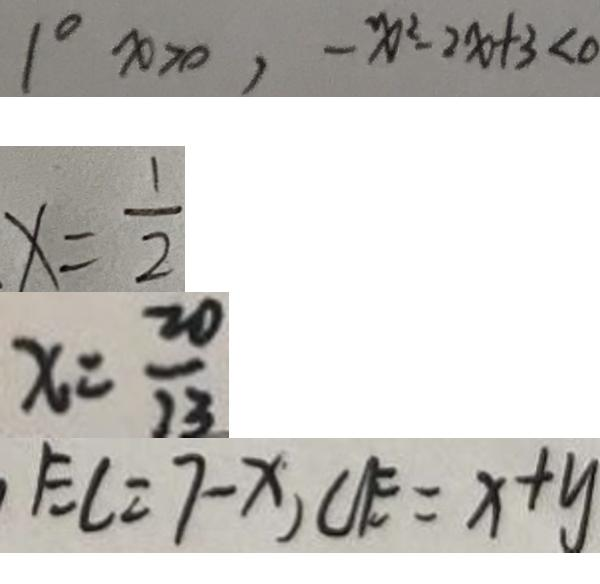Convert formula to latex. <formula><loc_0><loc_0><loc_500><loc_500>1 ^ { \circ } x > 0 , - x ^ { 2 } - 2 x + 3 < 0 
 x = \frac { 1 } { 2 } 
 x = \frac { 2 0 } { 2 3 } 
 E C = 7 - x , C E = x + y</formula> 